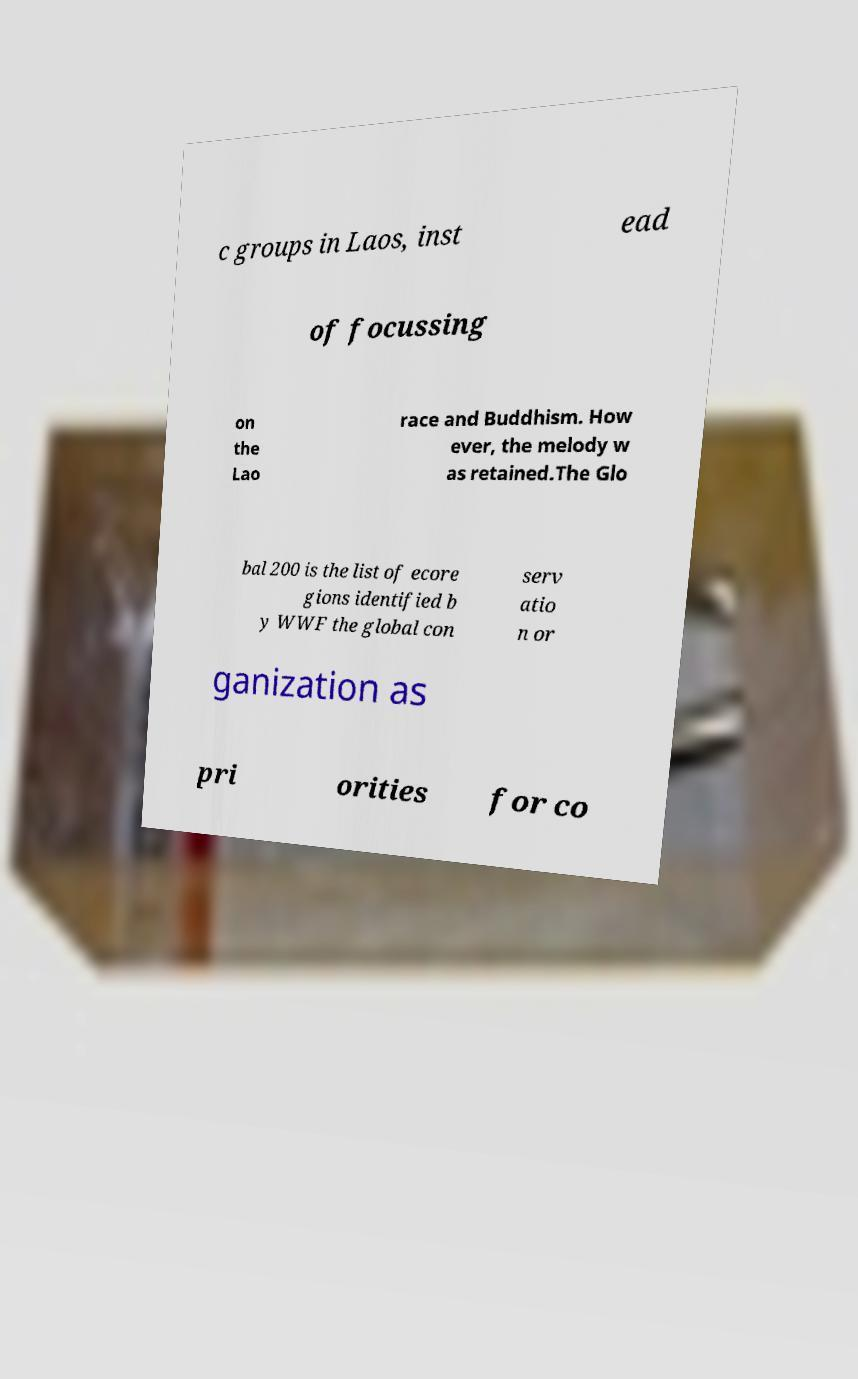Can you accurately transcribe the text from the provided image for me? c groups in Laos, inst ead of focussing on the Lao race and Buddhism. How ever, the melody w as retained.The Glo bal 200 is the list of ecore gions identified b y WWF the global con serv atio n or ganization as pri orities for co 